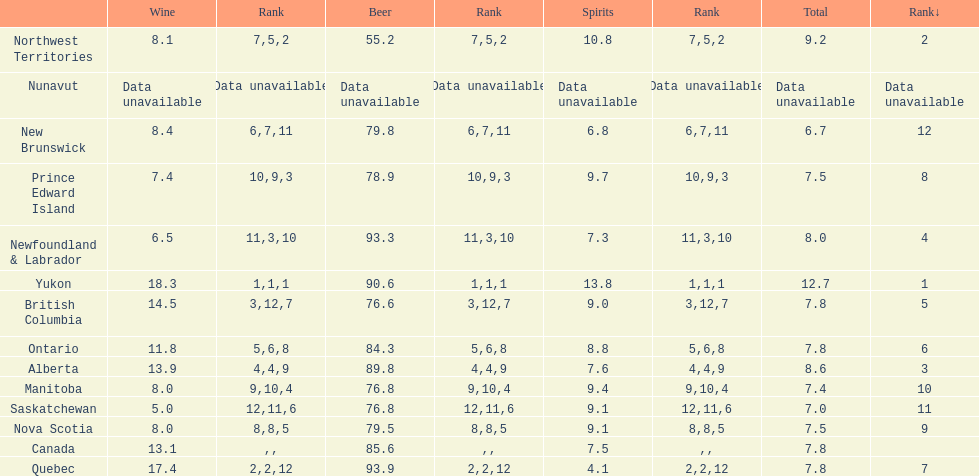Quebuec had a beer consumption of 93.9, what was their spirit consumption? 4.1. 